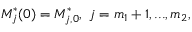Convert formula to latex. <formula><loc_0><loc_0><loc_500><loc_500>M _ { j } ^ { * } ( 0 ) = M _ { j , 0 } ^ { * } , \ j = m _ { 1 } + 1 , \dots , m _ { 2 } ,</formula> 